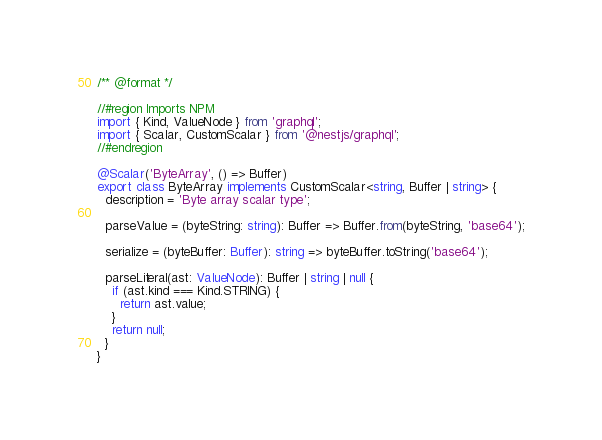Convert code to text. <code><loc_0><loc_0><loc_500><loc_500><_TypeScript_>/** @format */

//#region Imports NPM
import { Kind, ValueNode } from 'graphql';
import { Scalar, CustomScalar } from '@nestjs/graphql';
//#endregion

@Scalar('ByteArray', () => Buffer)
export class ByteArray implements CustomScalar<string, Buffer | string> {
  description = 'Byte array scalar type';

  parseValue = (byteString: string): Buffer => Buffer.from(byteString, 'base64');

  serialize = (byteBuffer: Buffer): string => byteBuffer.toString('base64');

  parseLiteral(ast: ValueNode): Buffer | string | null {
    if (ast.kind === Kind.STRING) {
      return ast.value;
    }
    return null;
  }
}
</code> 